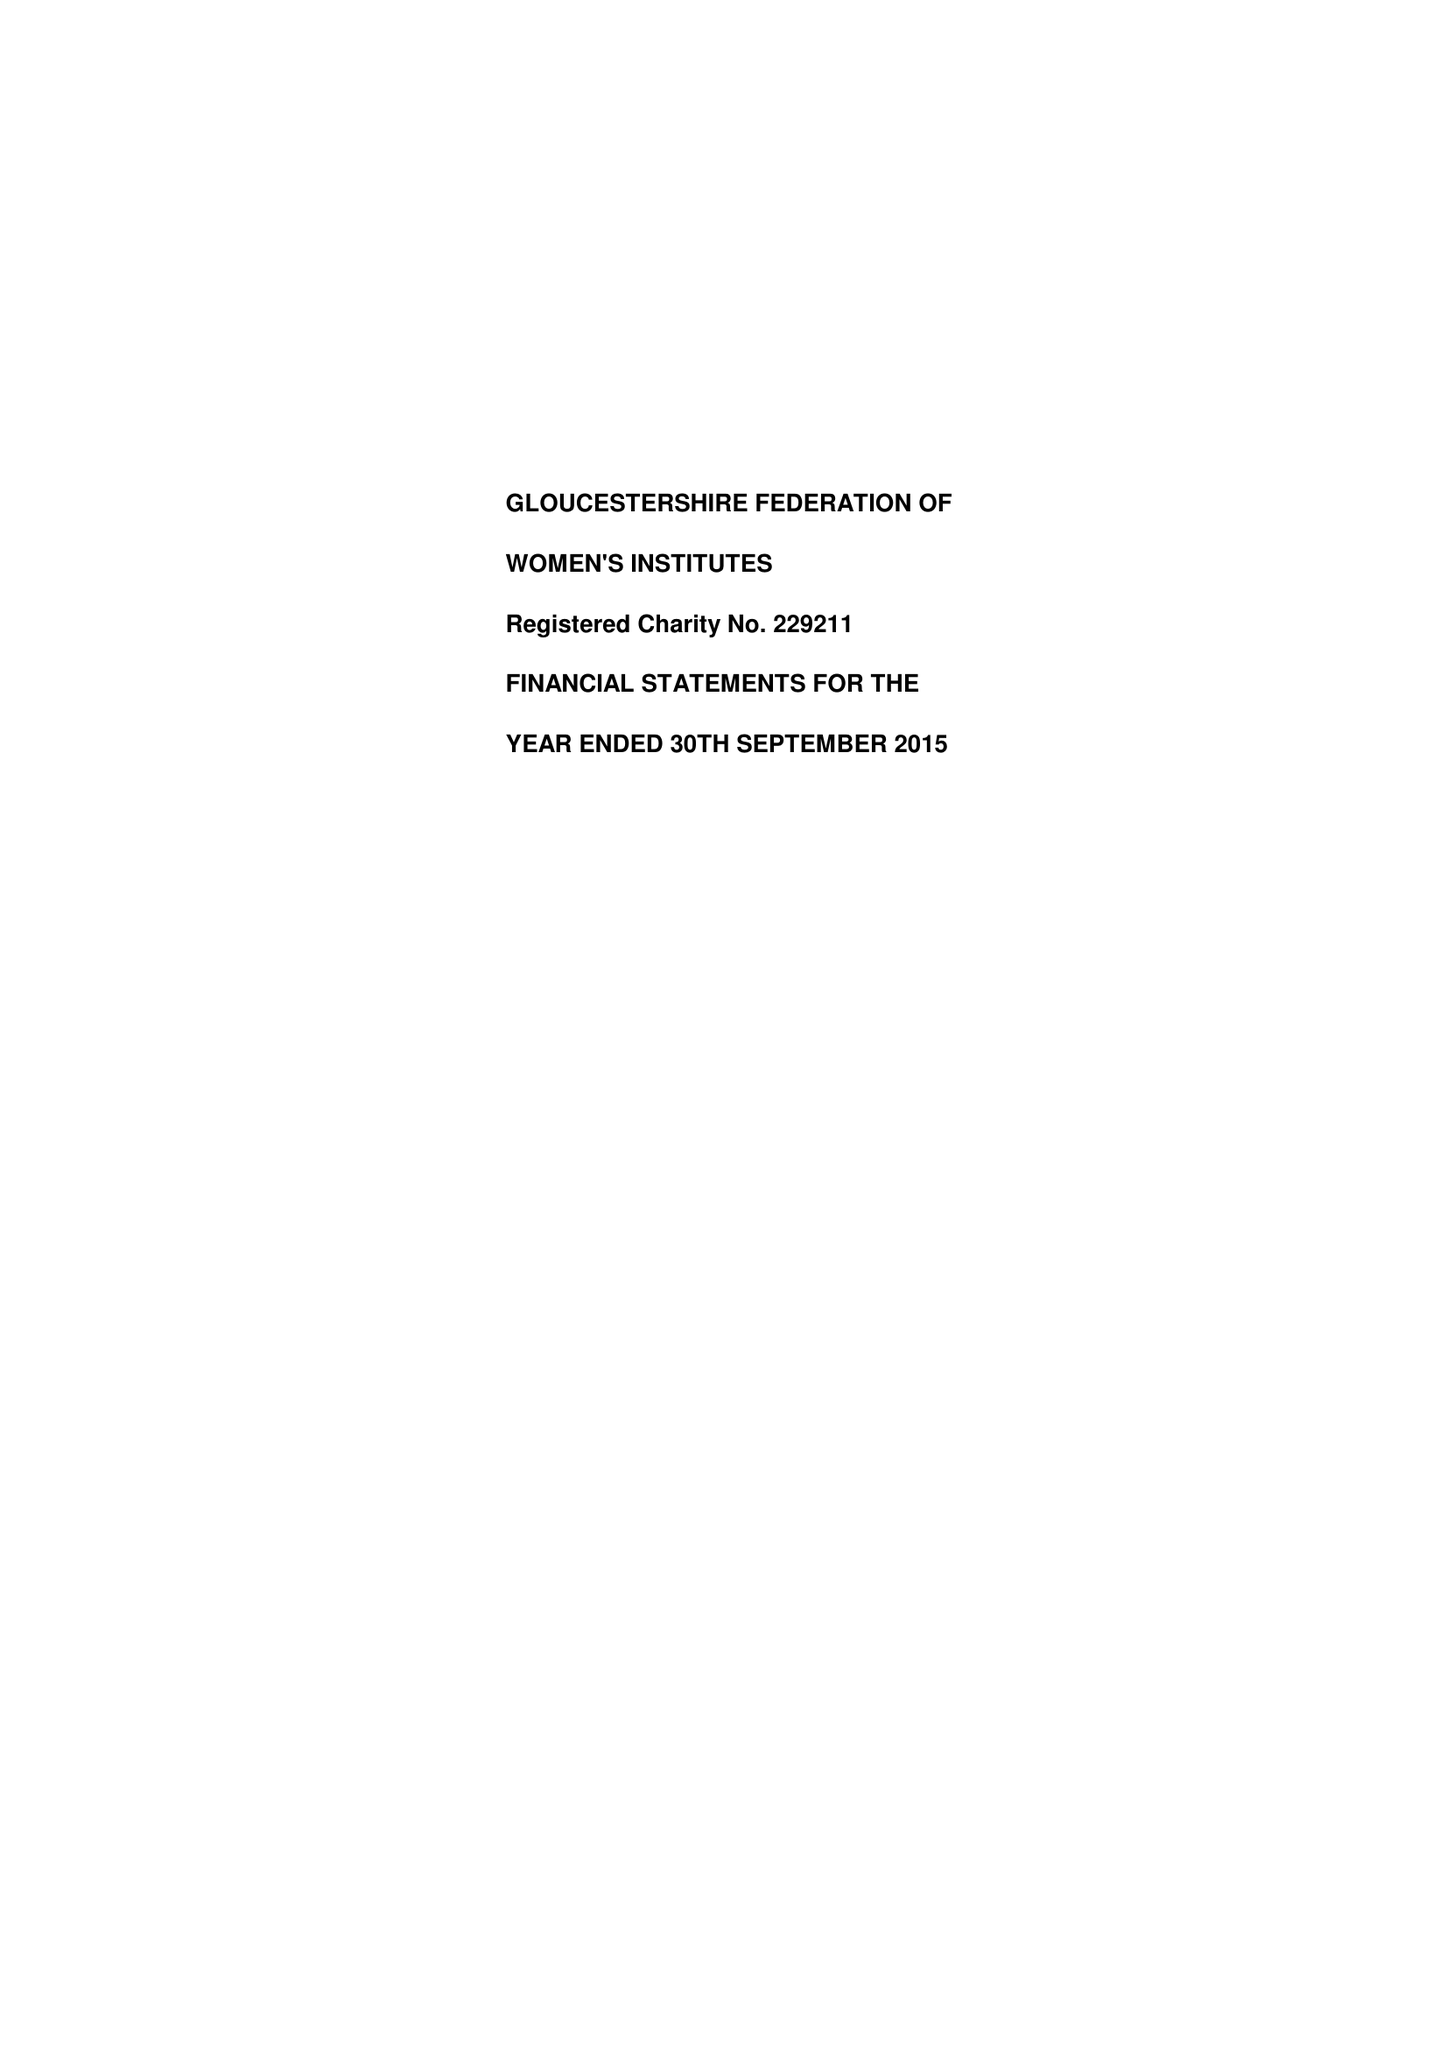What is the value for the charity_number?
Answer the question using a single word or phrase. 229211 